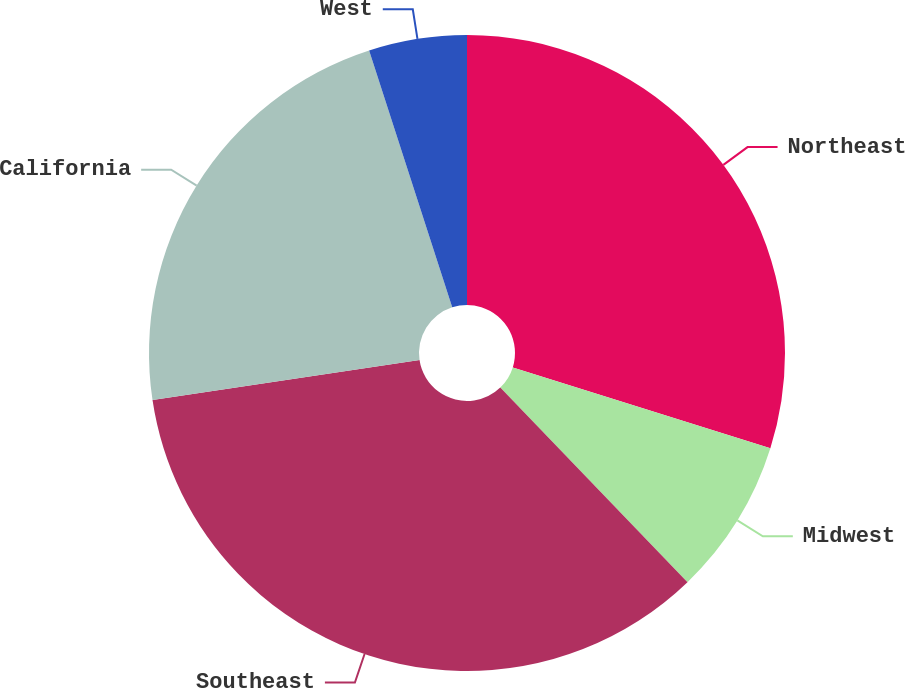<chart> <loc_0><loc_0><loc_500><loc_500><pie_chart><fcel>Northeast<fcel>Midwest<fcel>Southeast<fcel>California<fcel>West<nl><fcel>29.85%<fcel>7.96%<fcel>34.83%<fcel>22.39%<fcel>4.98%<nl></chart> 